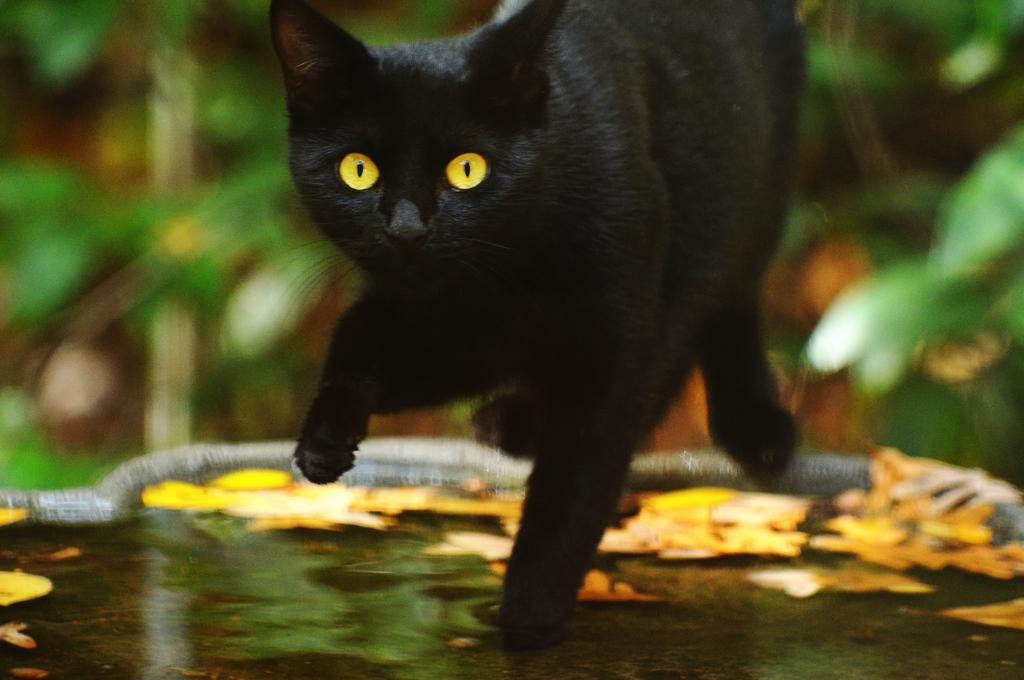What animal is in the middle of the picture? There is a black cat in the middle of the picture. What can be seen at the bottom of the picture? There is water visible at the bottom of the picture. How would you describe the background of the image? The background of the image is blurred. What type of juice is being poured by the cat in the image? There is no juice or any indication of pouring in the image; it features a black cat in the middle of the picture with water visible at the bottom. 